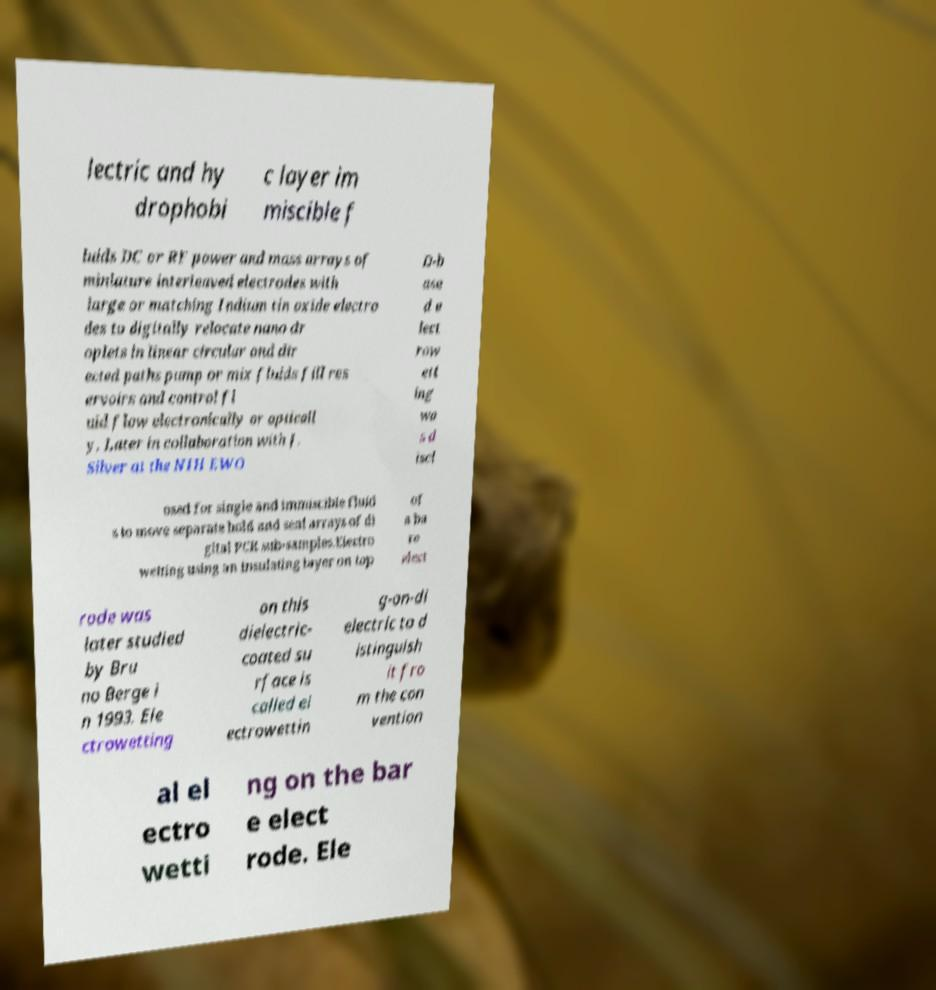Can you accurately transcribe the text from the provided image for me? lectric and hy drophobi c layer im miscible f luids DC or RF power and mass arrays of miniature interleaved electrodes with large or matching Indium tin oxide electro des to digitally relocate nano dr oplets in linear circular and dir ected paths pump or mix fluids fill res ervoirs and control fl uid flow electronically or opticall y. Later in collaboration with J. Silver at the NIH EWO D-b ase d e lect row ett ing wa s d iscl osed for single and immiscible fluid s to move separate hold and seal arrays of di gital PCR sub-samples.Electro wetting using an insulating layer on top of a ba re elect rode was later studied by Bru no Berge i n 1993. Ele ctrowetting on this dielectric- coated su rface is called el ectrowettin g-on-di electric to d istinguish it fro m the con vention al el ectro wetti ng on the bar e elect rode. Ele 